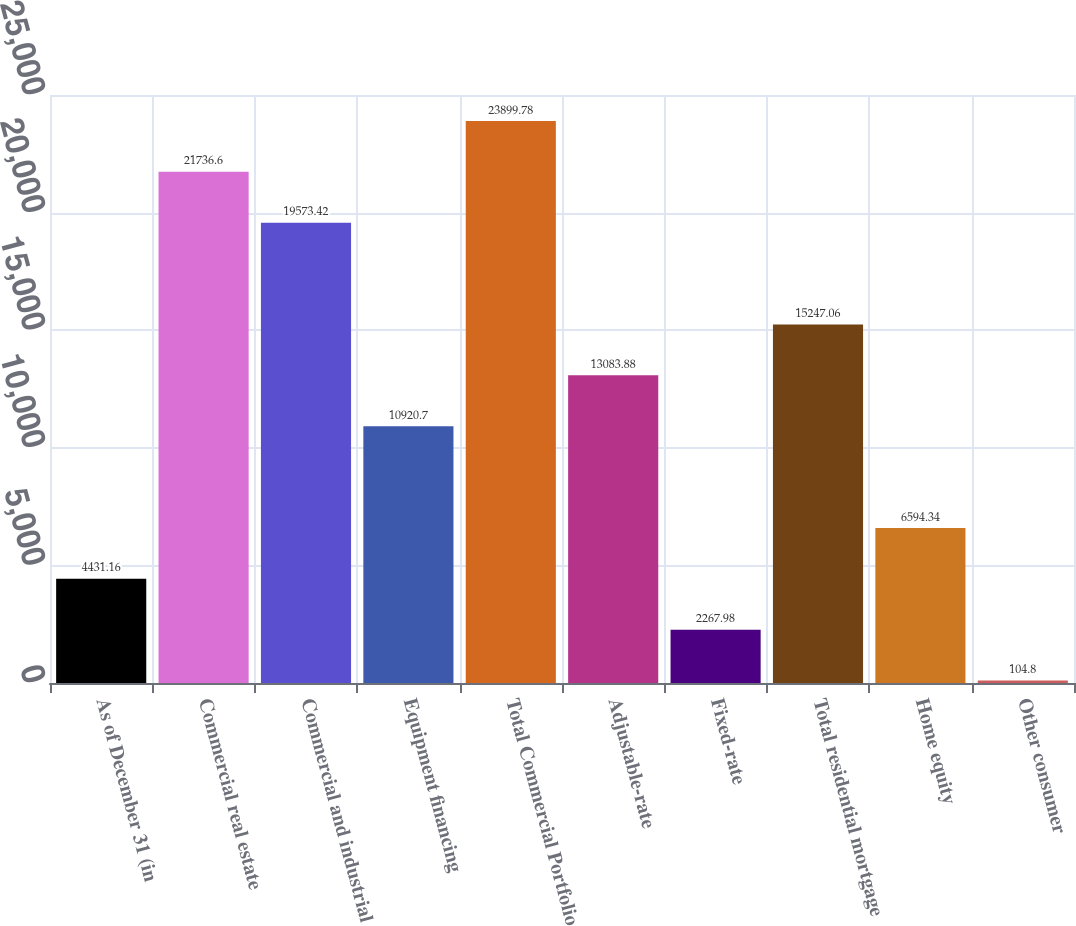Convert chart. <chart><loc_0><loc_0><loc_500><loc_500><bar_chart><fcel>As of December 31 (in<fcel>Commercial real estate<fcel>Commercial and industrial<fcel>Equipment financing<fcel>Total Commercial Portfolio<fcel>Adjustable-rate<fcel>Fixed-rate<fcel>Total residential mortgage<fcel>Home equity<fcel>Other consumer<nl><fcel>4431.16<fcel>21736.6<fcel>19573.4<fcel>10920.7<fcel>23899.8<fcel>13083.9<fcel>2267.98<fcel>15247.1<fcel>6594.34<fcel>104.8<nl></chart> 